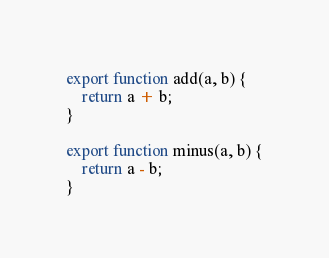Convert code to text. <code><loc_0><loc_0><loc_500><loc_500><_TypeScript_>export function add(a, b) {
    return a + b;
}

export function minus(a, b) {
    return a - b;
}</code> 